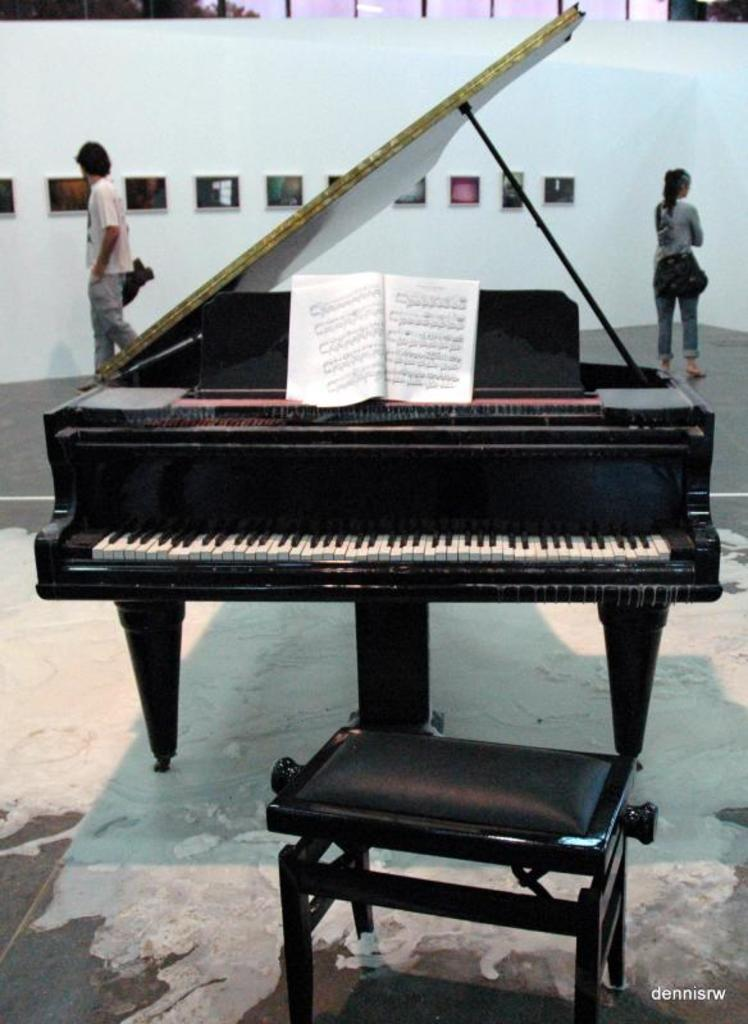What musical instrument is present in the image? There is a piano in the image. What object related to reading can be seen in the image? There is a book in the image. What piece of furniture is present in the image? There is a stool in the image. How many people are visible in the background of the image? There are two people in the background of the image. What type of decoration is present on the wall in the background of the image? There are frames on the wall in the background of the image. What type of door can be seen in the image? There is no door present in the image. Who is the uncle in the image? There is no uncle mentioned or depicted in the image. 